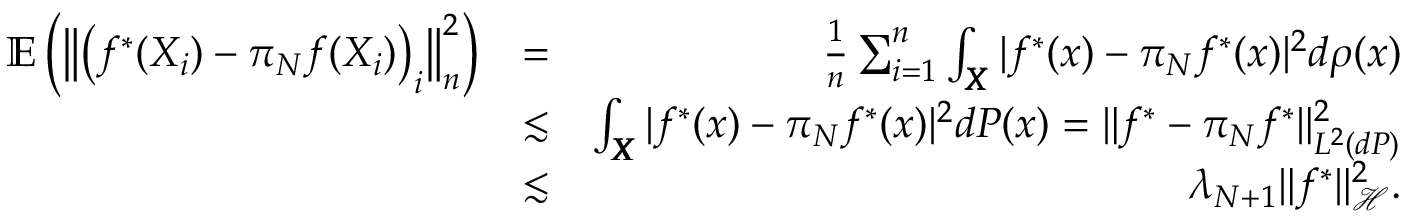<formula> <loc_0><loc_0><loc_500><loc_500>\begin{array} { r l r } { \mathbb { E } \left ( \left \| \left ( f ^ { * } ( X _ { i } ) - \pi _ { N } f ( X _ { i } ) \right ) _ { i } \right \| _ { n } ^ { 2 } \right ) } & { = } & { \frac { 1 } { n } \sum _ { i = 1 } ^ { n } \int _ { \pm b X } | f ^ { * } ( x ) - \pi _ { N } f ^ { * } ( x ) | ^ { 2 } d \rho ( x ) } \\ & { \lesssim } & { \int _ { \pm b X } | f ^ { * } ( x ) - \pi _ { N } f ^ { * } ( x ) | ^ { 2 } d P ( x ) = \| f ^ { * } - \pi _ { N } f ^ { * } \| _ { L ^ { 2 } ( d P ) } ^ { 2 } } \\ & { \lesssim } & { \lambda _ { N + 1 } \| f ^ { * } \| _ { \mathcal { H } } ^ { 2 } . } \end{array}</formula> 